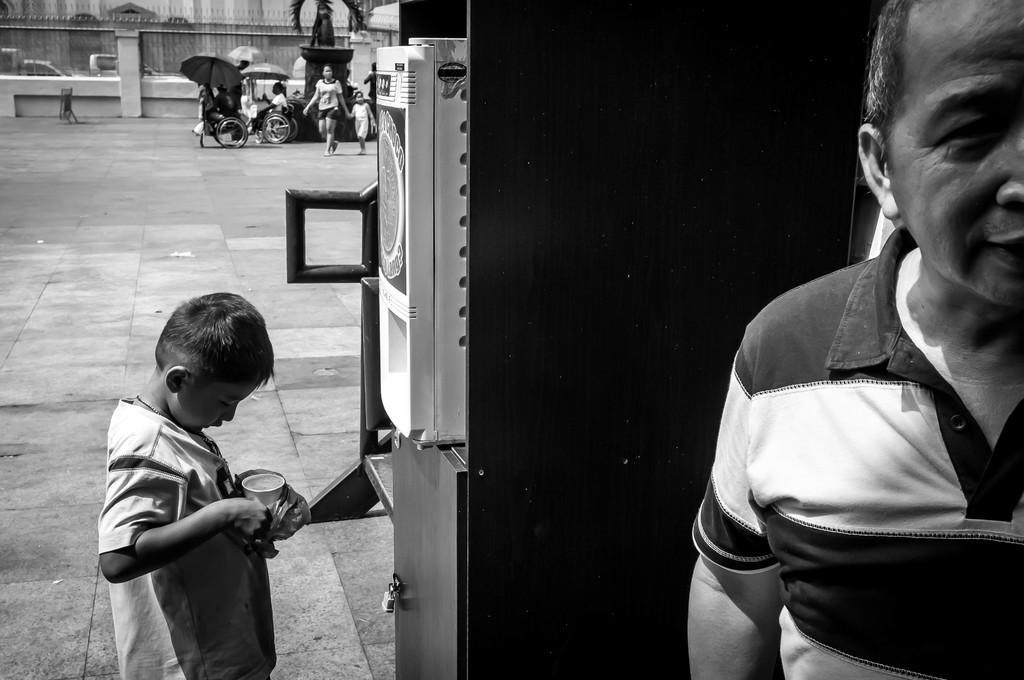Please provide a concise description of this image. In this image there is a person , a kid standing and holding a glass, a machine, people sitting on the wheel chairs and holding umbrellas, sculpture, people standing, building, cars. 